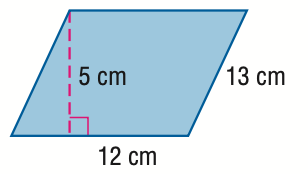Answer the mathemtical geometry problem and directly provide the correct option letter.
Question: Find the area of the parallelogram. Round to the nearest tenth if necessary.
Choices: A: 30 B: 50 C: 60 D: 156 C 